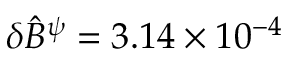Convert formula to latex. <formula><loc_0><loc_0><loc_500><loc_500>\delta \hat { B } ^ { \psi } = 3 . 1 4 \times 1 0 ^ { - 4 }</formula> 